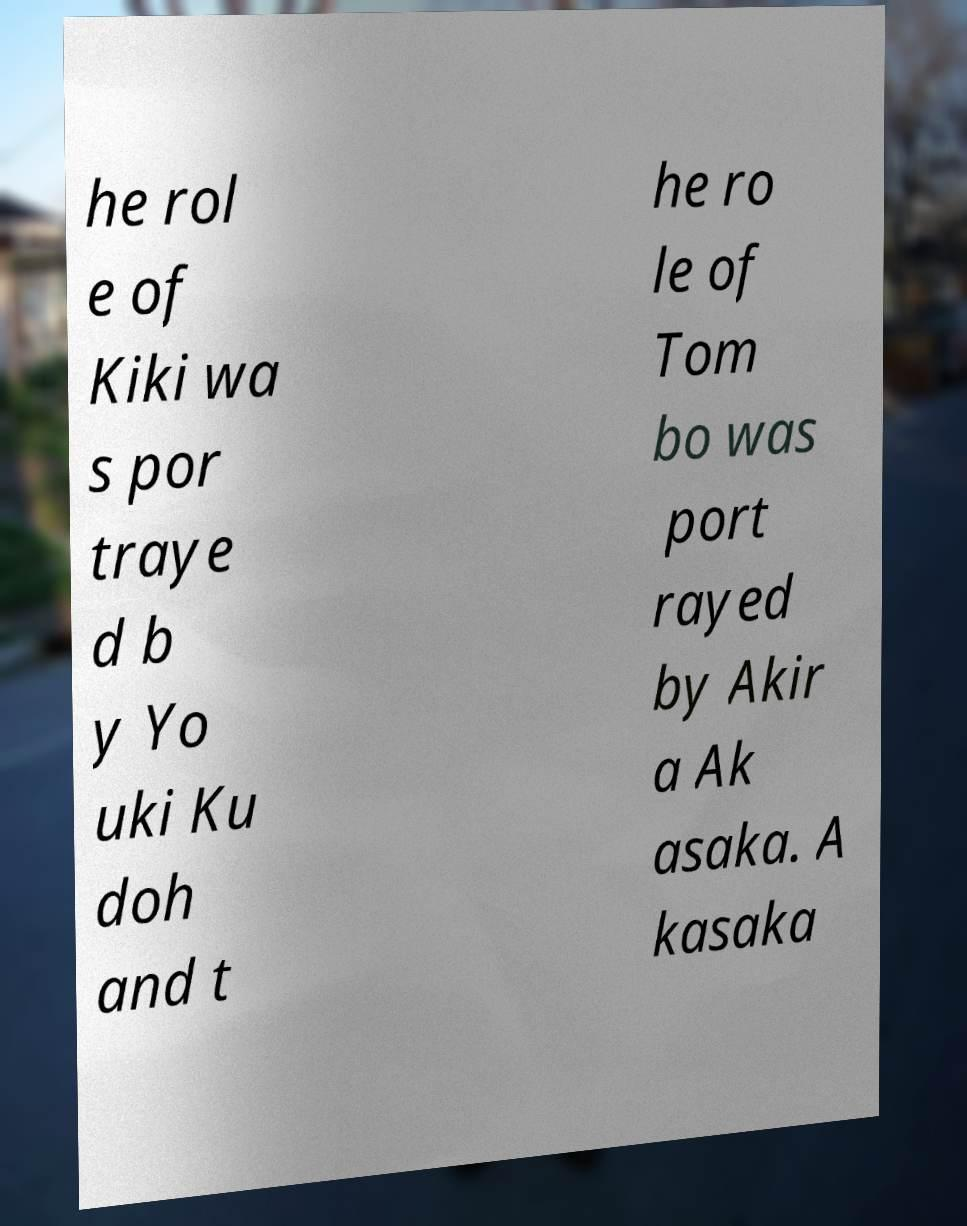For documentation purposes, I need the text within this image transcribed. Could you provide that? he rol e of Kiki wa s por traye d b y Yo uki Ku doh and t he ro le of Tom bo was port rayed by Akir a Ak asaka. A kasaka 